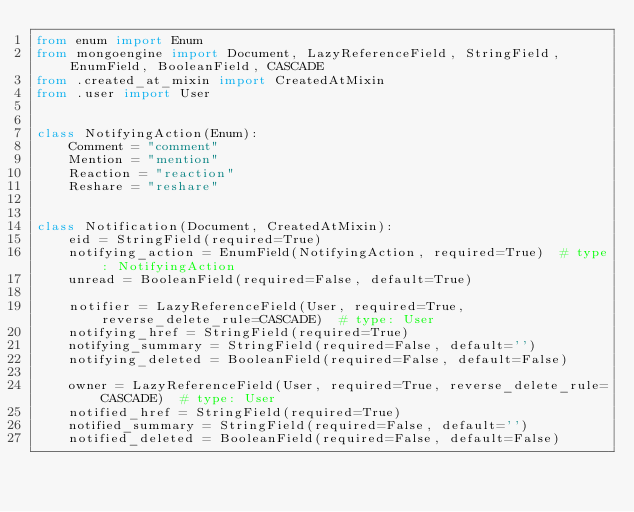Convert code to text. <code><loc_0><loc_0><loc_500><loc_500><_Python_>from enum import Enum
from mongoengine import Document, LazyReferenceField, StringField, EnumField, BooleanField, CASCADE
from .created_at_mixin import CreatedAtMixin
from .user import User


class NotifyingAction(Enum):
    Comment = "comment"
    Mention = "mention"
    Reaction = "reaction"
    Reshare = "reshare"


class Notification(Document, CreatedAtMixin):
    eid = StringField(required=True)
    notifying_action = EnumField(NotifyingAction, required=True)  # type: NotifyingAction
    unread = BooleanField(required=False, default=True)

    notifier = LazyReferenceField(User, required=True, reverse_delete_rule=CASCADE)  # type: User
    notifying_href = StringField(required=True)
    notifying_summary = StringField(required=False, default='')
    notifying_deleted = BooleanField(required=False, default=False)

    owner = LazyReferenceField(User, required=True, reverse_delete_rule=CASCADE)  # type: User
    notified_href = StringField(required=True)
    notified_summary = StringField(required=False, default='')
    notified_deleted = BooleanField(required=False, default=False)
</code> 